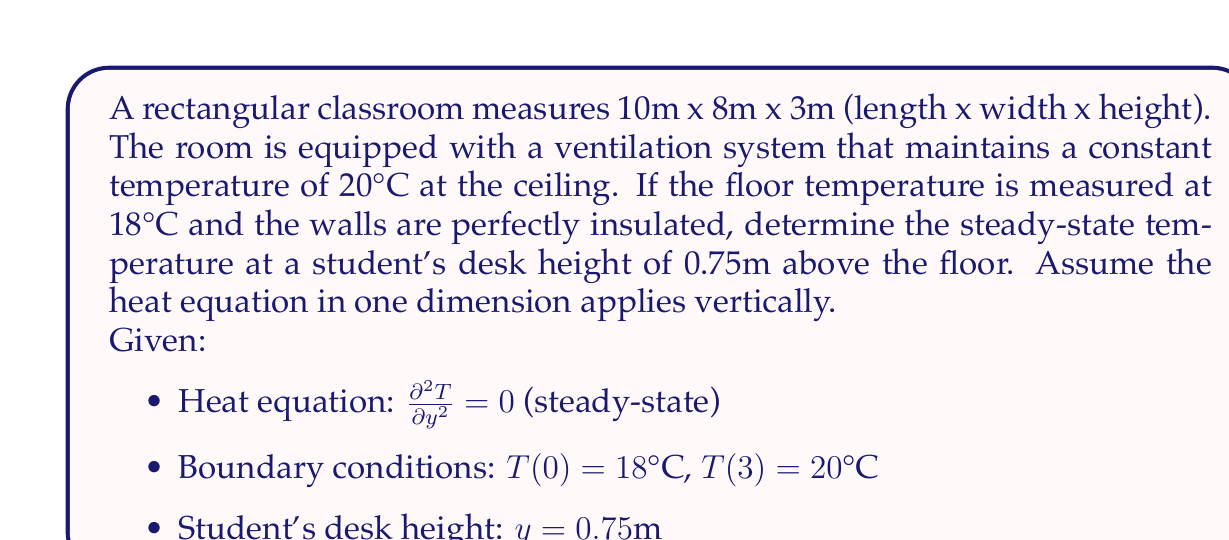Provide a solution to this math problem. To solve this problem, we'll follow these steps:

1) The steady-state heat equation in one dimension is:

   $$\frac{\partial^2 T}{\partial y^2} = 0$$

2) Integrating twice with respect to y:

   $$\frac{\partial T}{\partial y} = C_1$$
   $$T(y) = C_1y + C_2$$

3) Apply the boundary conditions:
   At $y = 0$, $T(0) = 18°C$: $18 = C_2$
   At $y = 3$, $T(3) = 20°C$: $20 = 3C_1 + 18$

4) Solve for $C_1$:
   $$20 - 18 = 3C_1$$
   $$C_1 = \frac{2}{3} = 0.667$$

5) The temperature distribution is thus:
   $$T(y) = 0.667y + 18$$

6) Calculate the temperature at the student's desk height ($y = 0.75m$):
   $$T(0.75) = 0.667(0.75) + 18 = 18.5°C$$
Answer: 18.5°C 